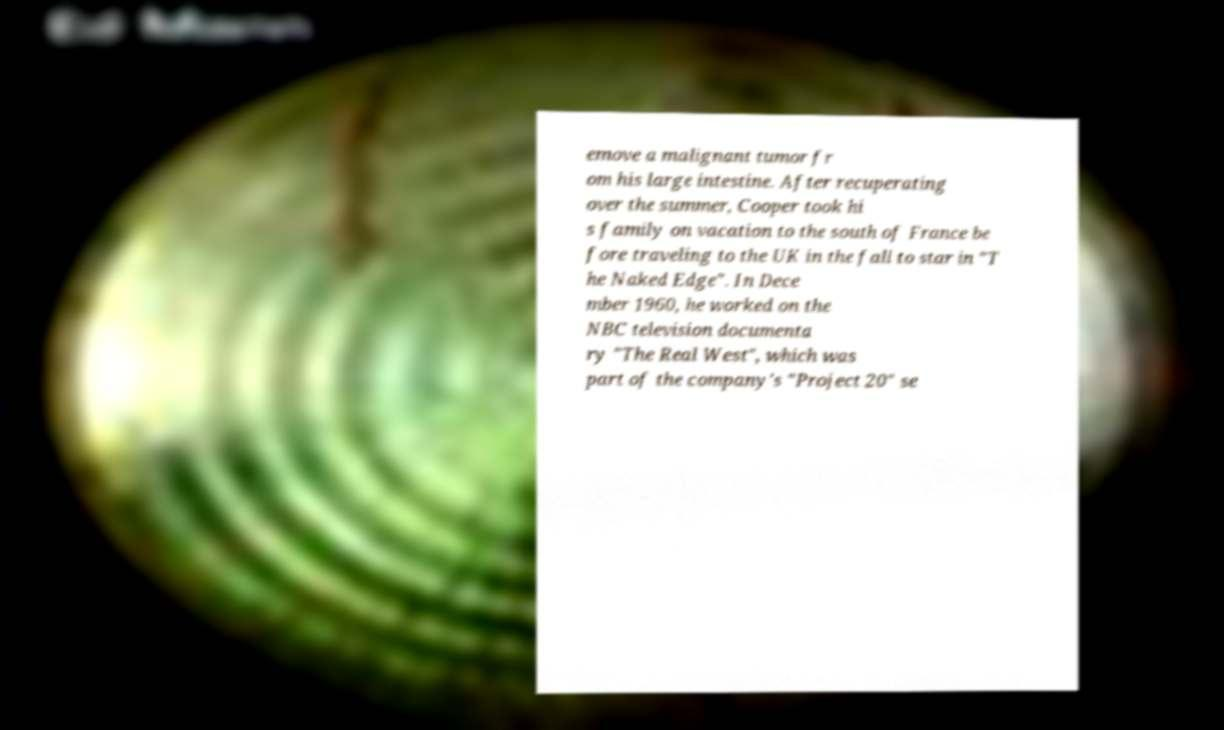Can you accurately transcribe the text from the provided image for me? emove a malignant tumor fr om his large intestine. After recuperating over the summer, Cooper took hi s family on vacation to the south of France be fore traveling to the UK in the fall to star in "T he Naked Edge". In Dece mber 1960, he worked on the NBC television documenta ry "The Real West", which was part of the company's "Project 20" se 